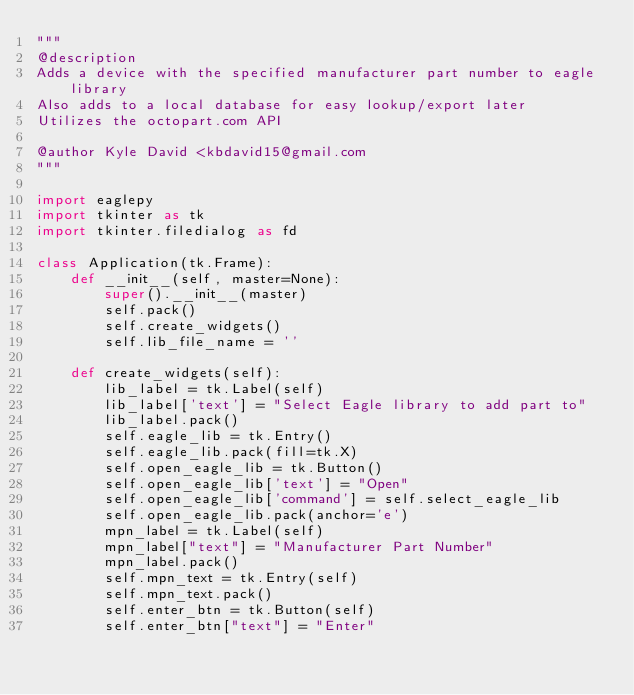Convert code to text. <code><loc_0><loc_0><loc_500><loc_500><_Python_>"""
@description
Adds a device with the specified manufacturer part number to eagle library
Also adds to a local database for easy lookup/export later
Utilizes the octopart.com API

@author Kyle David <kbdavid15@gmail.com
"""

import eaglepy
import tkinter as tk
import tkinter.filedialog as fd

class Application(tk.Frame):
    def __init__(self, master=None):
        super().__init__(master)
        self.pack()
        self.create_widgets()
        self.lib_file_name = ''

    def create_widgets(self):
        lib_label = tk.Label(self)
        lib_label['text'] = "Select Eagle library to add part to"
        lib_label.pack()
        self.eagle_lib = tk.Entry()
        self.eagle_lib.pack(fill=tk.X)
        self.open_eagle_lib = tk.Button()
        self.open_eagle_lib['text'] = "Open"
        self.open_eagle_lib['command'] = self.select_eagle_lib
        self.open_eagle_lib.pack(anchor='e')
        mpn_label = tk.Label(self)
        mpn_label["text"] = "Manufacturer Part Number"
        mpn_label.pack()
        self.mpn_text = tk.Entry(self)
        self.mpn_text.pack()
        self.enter_btn = tk.Button(self)
        self.enter_btn["text"] = "Enter"</code> 